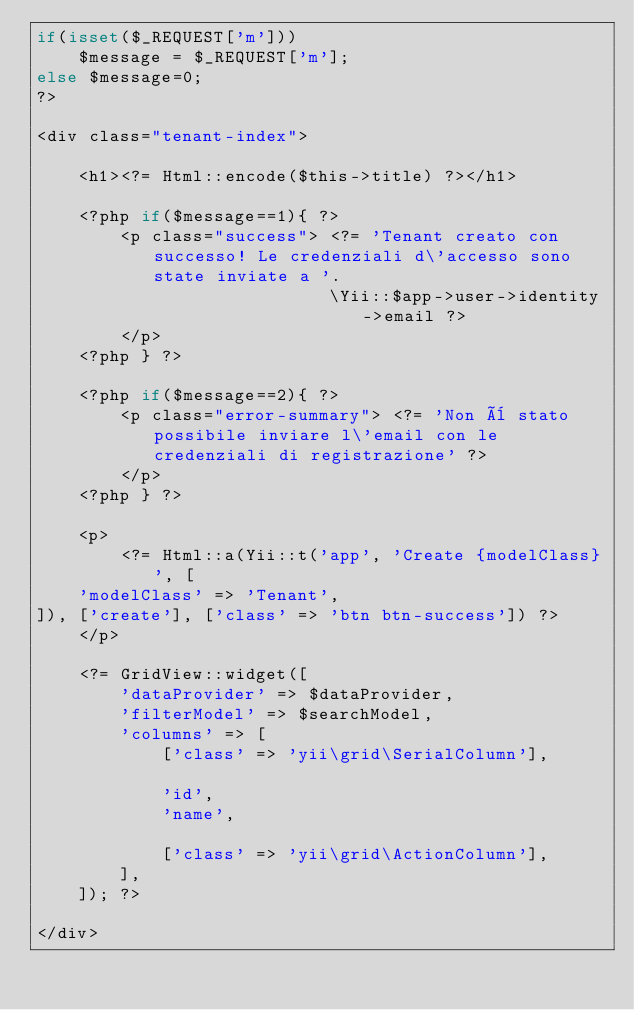Convert code to text. <code><loc_0><loc_0><loc_500><loc_500><_PHP_>if(isset($_REQUEST['m']))
    $message = $_REQUEST['m'];
else $message=0;
?>

<div class="tenant-index">

    <h1><?= Html::encode($this->title) ?></h1>

    <?php if($message==1){ ?>
        <p class="success"> <?= 'Tenant creato con successo! Le credenziali d\'accesso sono state inviate a '. 
                            \Yii::$app->user->identity->email ?> 
        </p>
    <?php } ?>  
      
    <?php if($message==2){ ?>          
        <p class="error-summary"> <?= 'Non è stato possibile inviare l\'email con le credenziali di registrazione' ?> 
        </p>
    <?php } ?>

    <p>
        <?= Html::a(Yii::t('app', 'Create {modelClass}', [
    'modelClass' => 'Tenant',
]), ['create'], ['class' => 'btn btn-success']) ?>
    </p>

    <?= GridView::widget([
        'dataProvider' => $dataProvider,
        'filterModel' => $searchModel,
        'columns' => [
            ['class' => 'yii\grid\SerialColumn'],

            'id',
            'name',

            ['class' => 'yii\grid\ActionColumn'],
        ],
    ]); ?>

</div>
</code> 